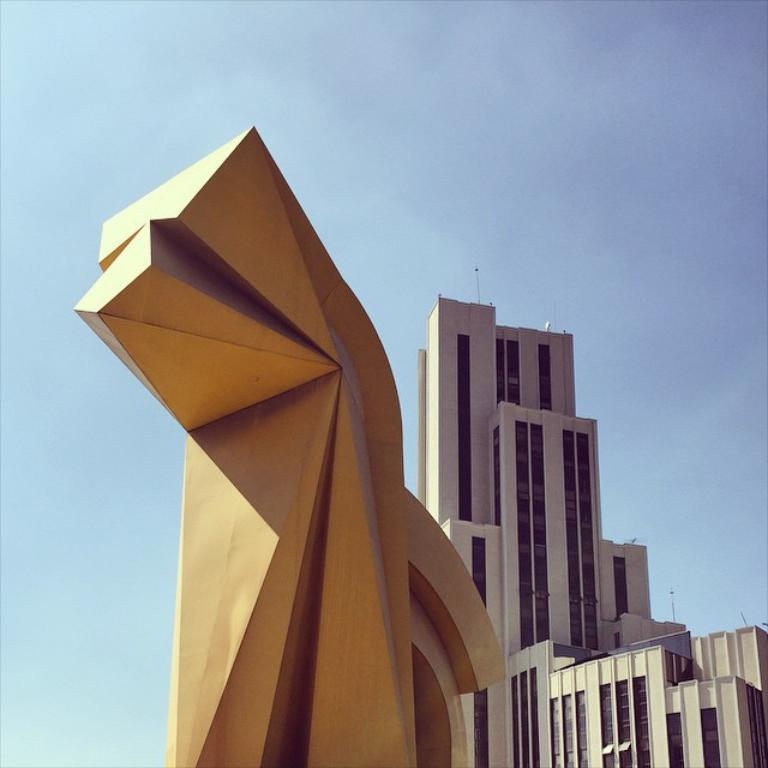What is located on the left side of the image? There is a golden color statue on the left side of the image. What can be seen on the right side of the image? There are buildings on the right side of the image. What is visible in the sky in the background of the image? There are clouds in the sky in the background of the image. How far away is the beetle from the statue in the image? There is no beetle present in the image, so it cannot be determined how far away it is from the statue. 